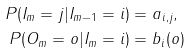Convert formula to latex. <formula><loc_0><loc_0><loc_500><loc_500>P ( I _ { m } = j | I _ { m - 1 } = i ) & = a _ { i , j } , \\ P ( O _ { m } = o | I _ { m } = i ) & = b _ { i } ( o )</formula> 